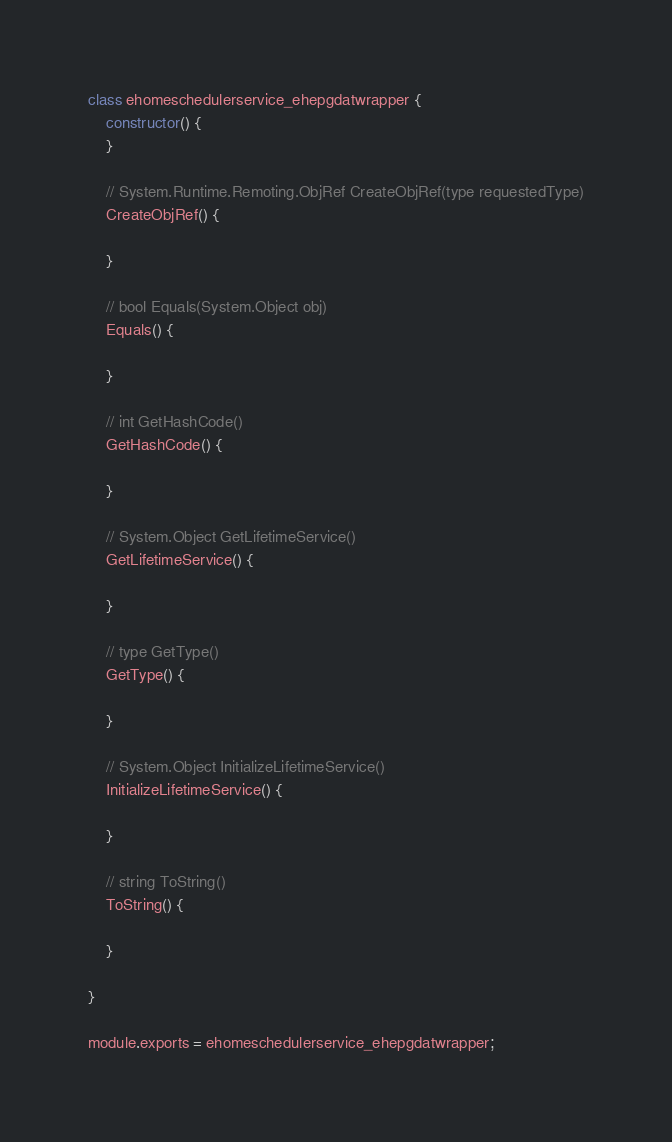<code> <loc_0><loc_0><loc_500><loc_500><_JavaScript_>class ehomeschedulerservice_ehepgdatwrapper {
    constructor() {
    }

    // System.Runtime.Remoting.ObjRef CreateObjRef(type requestedType)
    CreateObjRef() {

    }

    // bool Equals(System.Object obj)
    Equals() {

    }

    // int GetHashCode()
    GetHashCode() {

    }

    // System.Object GetLifetimeService()
    GetLifetimeService() {

    }

    // type GetType()
    GetType() {

    }

    // System.Object InitializeLifetimeService()
    InitializeLifetimeService() {

    }

    // string ToString()
    ToString() {

    }

}

module.exports = ehomeschedulerservice_ehepgdatwrapper;

</code> 